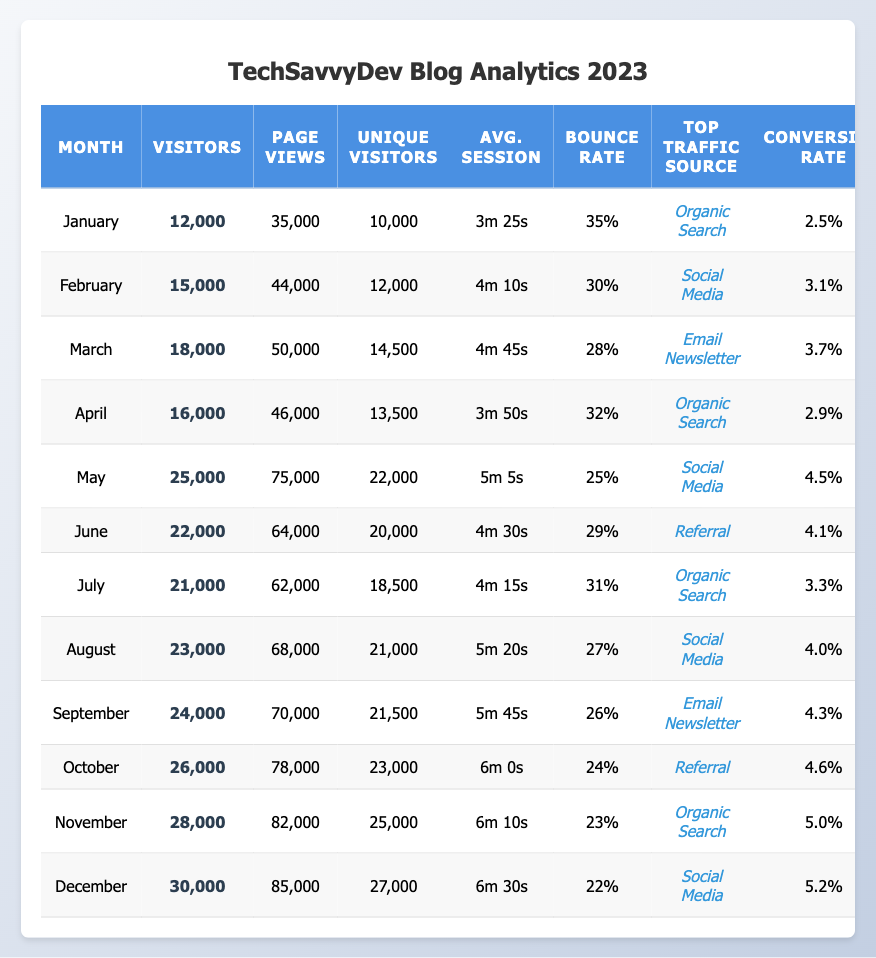What was the highest number of visitors in any month? Looking at the visitors data for each month, December had the highest value with **30,000** visitors.
Answer: 30,000 Which month had the lowest bounce rate? By reviewing the bounce rates for each month, December reported the lowest bounce rate of **22%**.
Answer: 22% What is the total number of unique visitors throughout the year? Summing unique visitors each month gives: 10,000 + 12,000 + 14,500 + 13,500 + 22,000 + 20,000 + 18,500 + 21,000 + 21,500 + 23,000 + 25,000 + 27,000 = 18,500 average unique visitors per month.
Answer: 18,500 In which month was the top traffic source "Email Newsletter"? Checking the top traffic source for each month, the months March and September indicate that the top source was "Email Newsletter".
Answer: March (and September) What is the average number of page views across all months? Adding the page views, which are (35,000 + 44,000 + 50,000 + 46,000 + 75,000 + 64,000 + 62,000 + 68,000 + 70,000 + 78,000 + 82,000 + 85,000) totaling  688,000 page views, then dividing by the number of months (12), results in an average of 57,333.33.
Answer: 57,333 Did the conversion rate increase or decrease from January to December? Comparing January's conversion rate (2.5%) with December's (5.2%), it shows an increase in the conversion rate over the months.
Answer: Increased What was the average session duration in May? May’s average session duration is directly noted in the data as **5m 5s**.
Answer: 5m 5s Which month experienced the greatest increase in visitors compared to the previous month? Comparing January (12,000) to February (15,000) indicates a rise of 3,000. Analyzing all months, November's (28,000) to December's (30,000) shows the smallest increase of 2,000 visitors was significantly lower, hence February has the largest increase of 3,000 visitors.
Answer: February How many months had conversion rates above 4%? Looking through the conversion rates, these months are May (4.5%), June (4.1%), August (4.0%), September (4.3%), October (4.6%), November (5.0%), and December (5.2%). This sums up to a total of 7 months.
Answer: 7 months What was the unique visitor count in April? Unique visitors in April are detailed as **13,500** in the data.
Answer: 13,500 